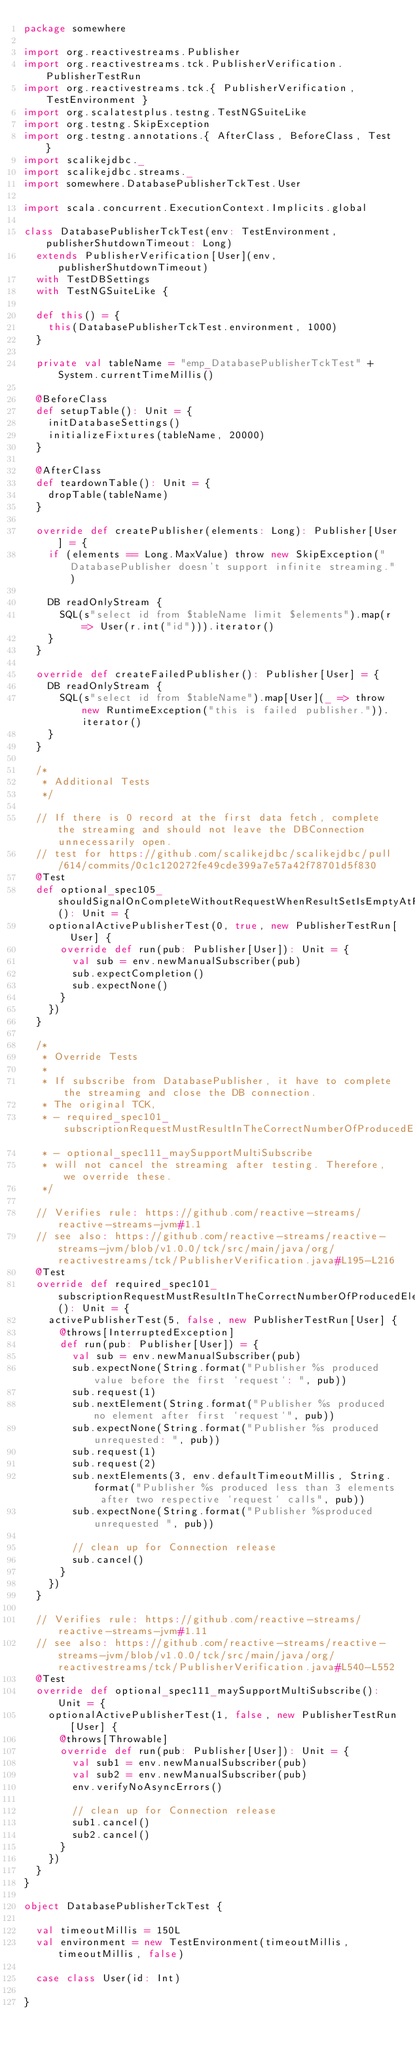Convert code to text. <code><loc_0><loc_0><loc_500><loc_500><_Scala_>package somewhere

import org.reactivestreams.Publisher
import org.reactivestreams.tck.PublisherVerification.PublisherTestRun
import org.reactivestreams.tck.{ PublisherVerification, TestEnvironment }
import org.scalatestplus.testng.TestNGSuiteLike
import org.testng.SkipException
import org.testng.annotations.{ AfterClass, BeforeClass, Test }
import scalikejdbc._
import scalikejdbc.streams._
import somewhere.DatabasePublisherTckTest.User

import scala.concurrent.ExecutionContext.Implicits.global

class DatabasePublisherTckTest(env: TestEnvironment, publisherShutdownTimeout: Long)
  extends PublisherVerification[User](env, publisherShutdownTimeout)
  with TestDBSettings
  with TestNGSuiteLike {

  def this() = {
    this(DatabasePublisherTckTest.environment, 1000)
  }

  private val tableName = "emp_DatabasePublisherTckTest" + System.currentTimeMillis()

  @BeforeClass
  def setupTable(): Unit = {
    initDatabaseSettings()
    initializeFixtures(tableName, 20000)
  }

  @AfterClass
  def teardownTable(): Unit = {
    dropTable(tableName)
  }

  override def createPublisher(elements: Long): Publisher[User] = {
    if (elements == Long.MaxValue) throw new SkipException("DatabasePublisher doesn't support infinite streaming.")

    DB readOnlyStream {
      SQL(s"select id from $tableName limit $elements").map(r => User(r.int("id"))).iterator()
    }
  }

  override def createFailedPublisher(): Publisher[User] = {
    DB readOnlyStream {
      SQL(s"select id from $tableName").map[User](_ => throw new RuntimeException("this is failed publisher.")).iterator()
    }
  }

  /*
   * Additional Tests
   */

  // If there is 0 record at the first data fetch, complete the streaming and should not leave the DBConnection unnecessarily open.
  // test for https://github.com/scalikejdbc/scalikejdbc/pull/614/commits/0c1c120272fe49cde399a7e57a42f78701d5f830
  @Test
  def optional_spec105_shouldSignalOnCompleteWithoutRequestWhenResultSetIsEmptyAtFirstFetch(): Unit = {
    optionalActivePublisherTest(0, true, new PublisherTestRun[User] {
      override def run(pub: Publisher[User]): Unit = {
        val sub = env.newManualSubscriber(pub)
        sub.expectCompletion()
        sub.expectNone()
      }
    })
  }

  /*
   * Override Tests
   *
   * If subscribe from DatabasePublisher, it have to complete the streaming and close the DB connection.
   * The original TCK,
   * - required_spec101_subscriptionRequestMustResultInTheCorrectNumberOfProducedElements
   * - optional_spec111_maySupportMultiSubscribe
   * will not cancel the streaming after testing. Therefore, we override these.
   */

  // Verifies rule: https://github.com/reactive-streams/reactive-streams-jvm#1.1
  // see also: https://github.com/reactive-streams/reactive-streams-jvm/blob/v1.0.0/tck/src/main/java/org/reactivestreams/tck/PublisherVerification.java#L195-L216
  @Test
  override def required_spec101_subscriptionRequestMustResultInTheCorrectNumberOfProducedElements(): Unit = {
    activePublisherTest(5, false, new PublisherTestRun[User] {
      @throws[InterruptedException]
      def run(pub: Publisher[User]) = {
        val sub = env.newManualSubscriber(pub)
        sub.expectNone(String.format("Publisher %s produced value before the first `request`: ", pub))
        sub.request(1)
        sub.nextElement(String.format("Publisher %s produced no element after first `request`", pub))
        sub.expectNone(String.format("Publisher %s produced unrequested: ", pub))
        sub.request(1)
        sub.request(2)
        sub.nextElements(3, env.defaultTimeoutMillis, String.format("Publisher %s produced less than 3 elements after two respective `request` calls", pub))
        sub.expectNone(String.format("Publisher %sproduced unrequested ", pub))

        // clean up for Connection release
        sub.cancel()
      }
    })
  }

  // Verifies rule: https://github.com/reactive-streams/reactive-streams-jvm#1.11
  // see also: https://github.com/reactive-streams/reactive-streams-jvm/blob/v1.0.0/tck/src/main/java/org/reactivestreams/tck/PublisherVerification.java#L540-L552
  @Test
  override def optional_spec111_maySupportMultiSubscribe(): Unit = {
    optionalActivePublisherTest(1, false, new PublisherTestRun[User] {
      @throws[Throwable]
      override def run(pub: Publisher[User]): Unit = {
        val sub1 = env.newManualSubscriber(pub)
        val sub2 = env.newManualSubscriber(pub)
        env.verifyNoAsyncErrors()

        // clean up for Connection release
        sub1.cancel()
        sub2.cancel()
      }
    })
  }
}

object DatabasePublisherTckTest {

  val timeoutMillis = 150L
  val environment = new TestEnvironment(timeoutMillis, timeoutMillis, false)

  case class User(id: Int)

}
</code> 